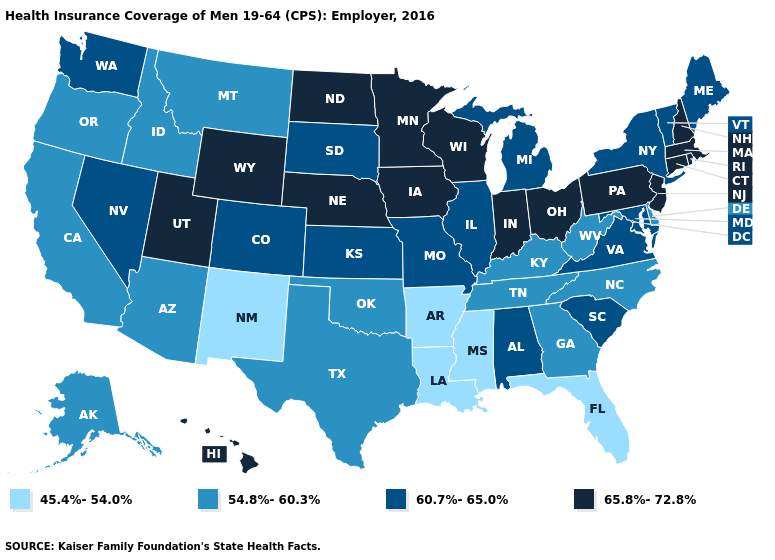Name the states that have a value in the range 45.4%-54.0%?
Write a very short answer. Arkansas, Florida, Louisiana, Mississippi, New Mexico. Name the states that have a value in the range 60.7%-65.0%?
Keep it brief. Alabama, Colorado, Illinois, Kansas, Maine, Maryland, Michigan, Missouri, Nevada, New York, South Carolina, South Dakota, Vermont, Virginia, Washington. Name the states that have a value in the range 65.8%-72.8%?
Give a very brief answer. Connecticut, Hawaii, Indiana, Iowa, Massachusetts, Minnesota, Nebraska, New Hampshire, New Jersey, North Dakota, Ohio, Pennsylvania, Rhode Island, Utah, Wisconsin, Wyoming. What is the lowest value in the West?
Keep it brief. 45.4%-54.0%. Does the first symbol in the legend represent the smallest category?
Concise answer only. Yes. Does Montana have the highest value in the USA?
Be succinct. No. Name the states that have a value in the range 65.8%-72.8%?
Write a very short answer. Connecticut, Hawaii, Indiana, Iowa, Massachusetts, Minnesota, Nebraska, New Hampshire, New Jersey, North Dakota, Ohio, Pennsylvania, Rhode Island, Utah, Wisconsin, Wyoming. Among the states that border North Carolina , which have the highest value?
Short answer required. South Carolina, Virginia. How many symbols are there in the legend?
Concise answer only. 4. What is the lowest value in the West?
Concise answer only. 45.4%-54.0%. What is the lowest value in the South?
Answer briefly. 45.4%-54.0%. Name the states that have a value in the range 54.8%-60.3%?
Keep it brief. Alaska, Arizona, California, Delaware, Georgia, Idaho, Kentucky, Montana, North Carolina, Oklahoma, Oregon, Tennessee, Texas, West Virginia. What is the value of South Carolina?
Keep it brief. 60.7%-65.0%. What is the value of Washington?
Be succinct. 60.7%-65.0%. 